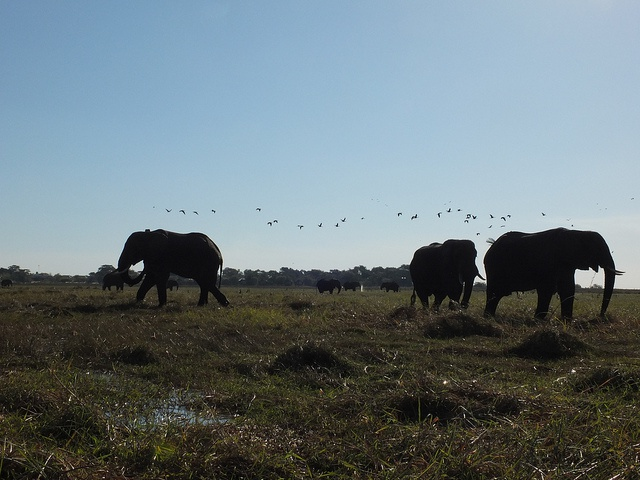Describe the objects in this image and their specific colors. I can see elephant in gray, black, lightgray, and darkgray tones, elephant in gray, black, darkgray, and lightblue tones, elephant in gray, black, lightgray, and darkgreen tones, bird in gray, lightblue, lightgray, and darkgray tones, and elephant in gray and black tones in this image. 